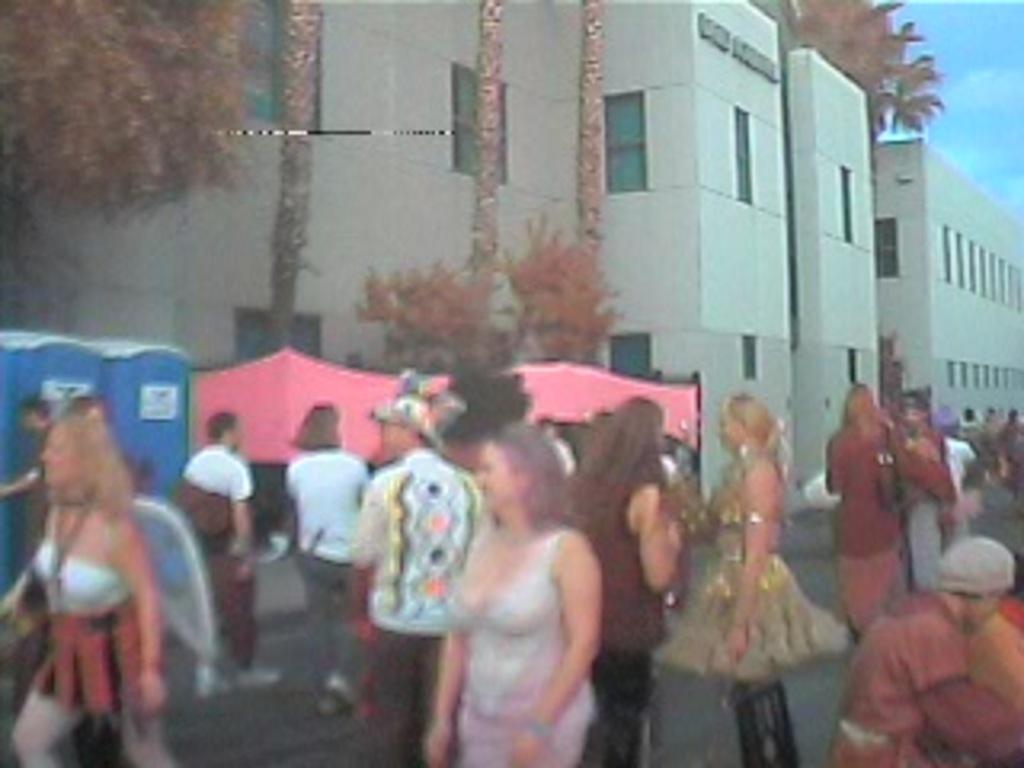What are the people in the image doing? There is a group of people standing on the road in the image. What can be seen in the background of the image? In the background of the image, there are tents, readymade toilet cabins, trees, buildings, and the sky. How many different types of structures are visible in the background? There are four different types of structures visible in the background: tents, toilet cabins, trees, and buildings. How many feet are visible in the image? There is no specific mention of feet in the image, so it is not possible to determine how many feet are visible. 